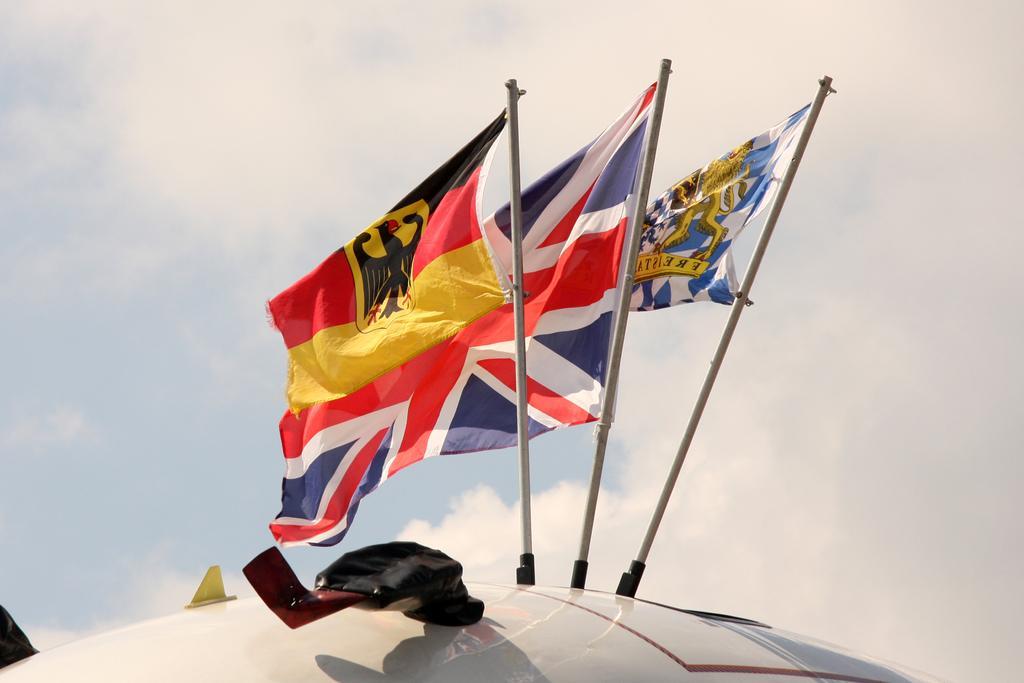Please provide a concise description of this image. In this image we can see three flags with poles on a metal object. Behind the flags we can see the sky. 